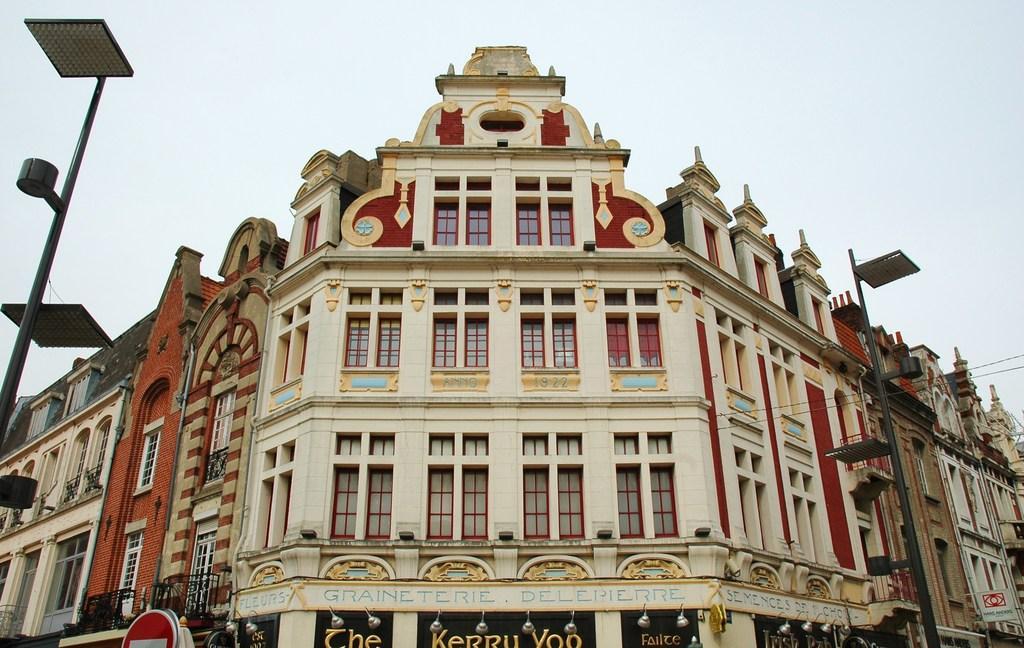In one or two sentences, can you explain what this image depicts? Here we can see a building, boards, lights, and poles. In the background there is sky. 